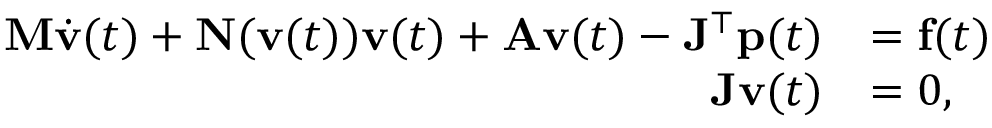Convert formula to latex. <formula><loc_0><loc_0><loc_500><loc_500>\begin{array} { r l } { { M } \dot { { v } } ( t ) + { N } ( { v } ( t ) ) { v } ( t ) + { A } { v } ( t ) - { J } ^ { \top } { p } ( t ) } & { = { f } ( t ) } \\ { { J } { v } ( t ) } & { = 0 , } \end{array}</formula> 